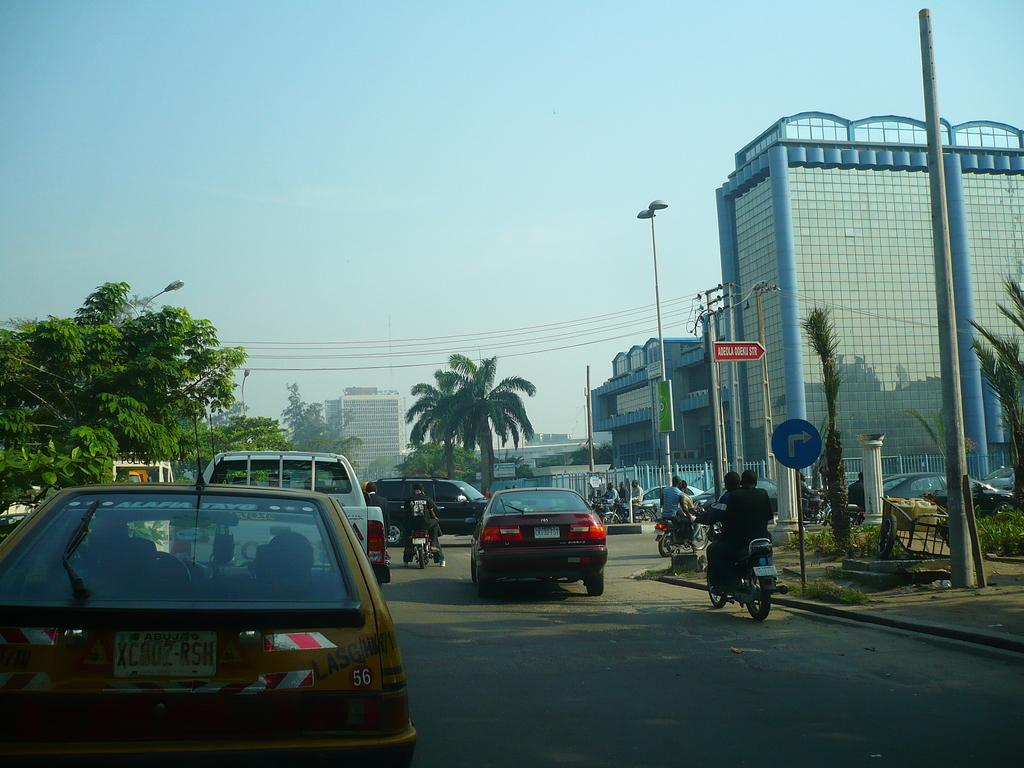What is happening in the center of the image? There are vehicles moving on the road in the center of the image. What can be seen in the distance behind the vehicles? There are buildings, trees, and poles in the background of the image. Are there any signs or messages visible in the image? Yes, there are boards with text written on them in the background of the image. What type of church can be seen in the image? There is no church present in the image. What idea does the text on the boards convey? The text on the boards cannot be determined from the image alone, as the content of the text is not visible. 